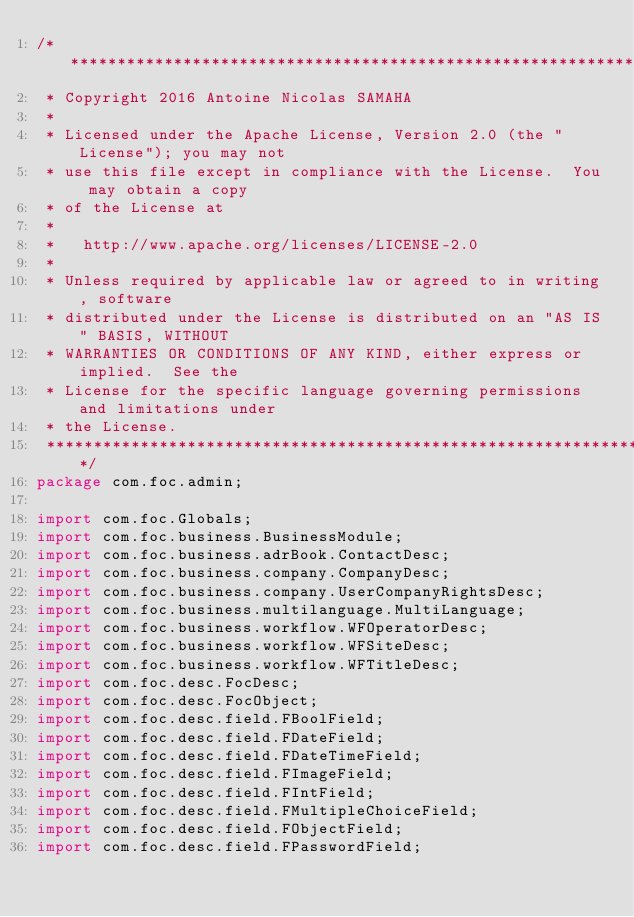Convert code to text. <code><loc_0><loc_0><loc_500><loc_500><_Java_>/*******************************************************************************
 * Copyright 2016 Antoine Nicolas SAMAHA
 * 
 * Licensed under the Apache License, Version 2.0 (the "License"); you may not
 * use this file except in compliance with the License.  You may obtain a copy
 * of the License at
 * 
 *   http://www.apache.org/licenses/LICENSE-2.0
 * 
 * Unless required by applicable law or agreed to in writing, software
 * distributed under the License is distributed on an "AS IS" BASIS, WITHOUT
 * WARRANTIES OR CONDITIONS OF ANY KIND, either express or implied.  See the
 * License for the specific language governing permissions and limitations under
 * the License.
 ******************************************************************************/
package com.foc.admin;

import com.foc.Globals;
import com.foc.business.BusinessModule;
import com.foc.business.adrBook.ContactDesc;
import com.foc.business.company.CompanyDesc;
import com.foc.business.company.UserCompanyRightsDesc;
import com.foc.business.multilanguage.MultiLanguage;
import com.foc.business.workflow.WFOperatorDesc;
import com.foc.business.workflow.WFSiteDesc;
import com.foc.business.workflow.WFTitleDesc;
import com.foc.desc.FocDesc;
import com.foc.desc.FocObject;
import com.foc.desc.field.FBoolField;
import com.foc.desc.field.FDateField;
import com.foc.desc.field.FDateTimeField;
import com.foc.desc.field.FImageField;
import com.foc.desc.field.FIntField;
import com.foc.desc.field.FMultipleChoiceField;
import com.foc.desc.field.FObjectField;
import com.foc.desc.field.FPasswordField;</code> 